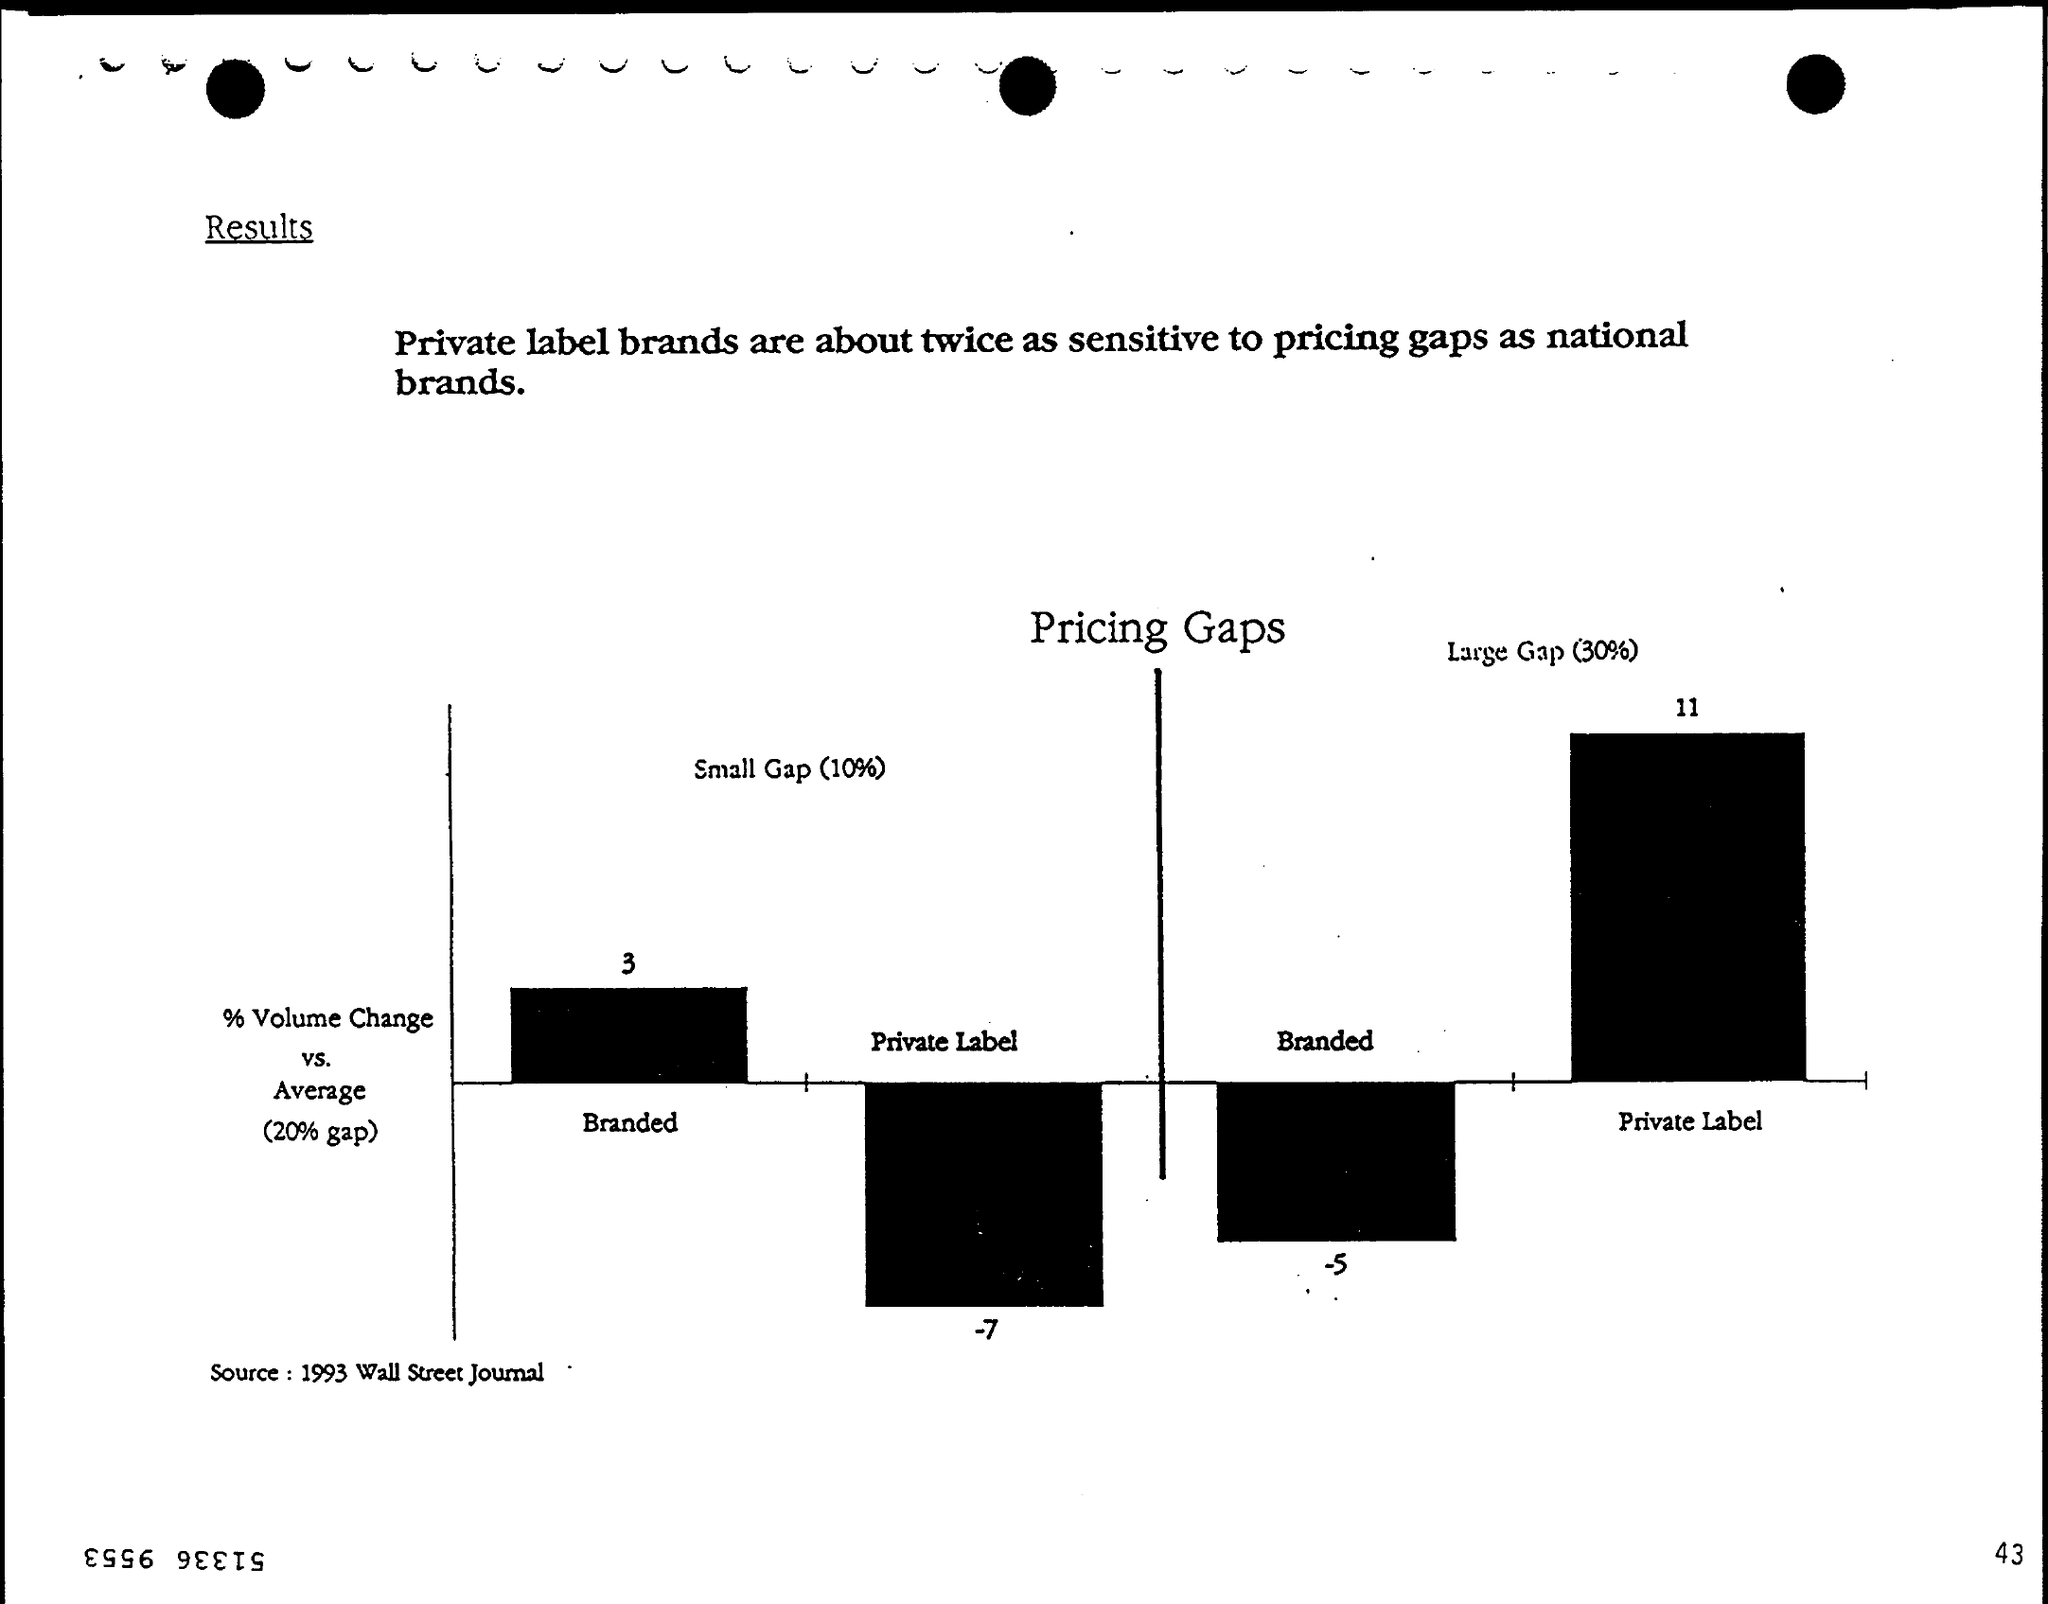What is the page number on this document?
Provide a short and direct response. 43. What is the source mentioned at the bottom of the page?
Keep it short and to the point. 1993 WALL STREET JOURNAL. 